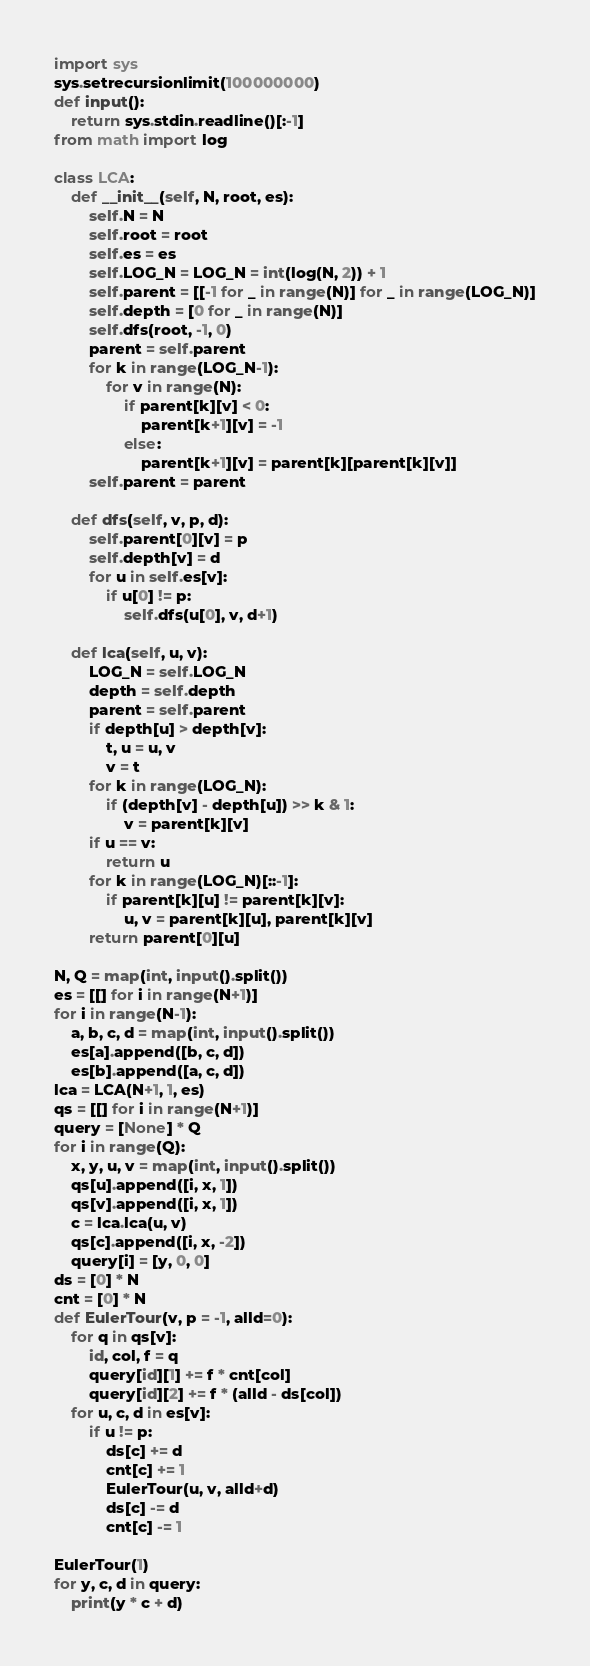<code> <loc_0><loc_0><loc_500><loc_500><_Python_>import sys
sys.setrecursionlimit(100000000)
def input():
    return sys.stdin.readline()[:-1]
from math import log

class LCA:
    def __init__(self, N, root, es):
        self.N = N
        self.root = root
        self.es = es
        self.LOG_N = LOG_N = int(log(N, 2)) + 1
        self.parent = [[-1 for _ in range(N)] for _ in range(LOG_N)]
        self.depth = [0 for _ in range(N)]
        self.dfs(root, -1, 0)
        parent = self.parent
        for k in range(LOG_N-1):
            for v in range(N):
                if parent[k][v] < 0:
                    parent[k+1][v] = -1
                else:
                    parent[k+1][v] = parent[k][parent[k][v]]
        self.parent = parent

    def dfs(self, v, p, d):
        self.parent[0][v] = p
        self.depth[v] = d
        for u in self.es[v]:
            if u[0] != p:
                self.dfs(u[0], v, d+1)

    def lca(self, u, v):
        LOG_N = self.LOG_N
        depth = self.depth
        parent = self.parent
        if depth[u] > depth[v]:
            t, u = u, v
            v = t
        for k in range(LOG_N):
            if (depth[v] - depth[u]) >> k & 1:
                v = parent[k][v]
        if u == v:
            return u
        for k in range(LOG_N)[::-1]:
            if parent[k][u] != parent[k][v]:
                u, v = parent[k][u], parent[k][v]
        return parent[0][u]

N, Q = map(int, input().split())
es = [[] for i in range(N+1)]
for i in range(N-1):
    a, b, c, d = map(int, input().split())
    es[a].append([b, c, d])
    es[b].append([a, c, d])
lca = LCA(N+1, 1, es)
qs = [[] for i in range(N+1)]
query = [None] * Q
for i in range(Q):
    x, y, u, v = map(int, input().split())
    qs[u].append([i, x, 1])
    qs[v].append([i, x, 1])
    c = lca.lca(u, v)
    qs[c].append([i, x, -2])
    query[i] = [y, 0, 0]
ds = [0] * N
cnt = [0] * N
def EulerTour(v, p = -1, alld=0):
    for q in qs[v]:
        id, col, f = q
        query[id][1] += f * cnt[col]
        query[id][2] += f * (alld - ds[col])
    for u, c, d in es[v]:
        if u != p:
            ds[c] += d
            cnt[c] += 1
            EulerTour(u, v, alld+d)
            ds[c] -= d
            cnt[c] -= 1

EulerTour(1)
for y, c, d in query:
    print(y * c + d)</code> 